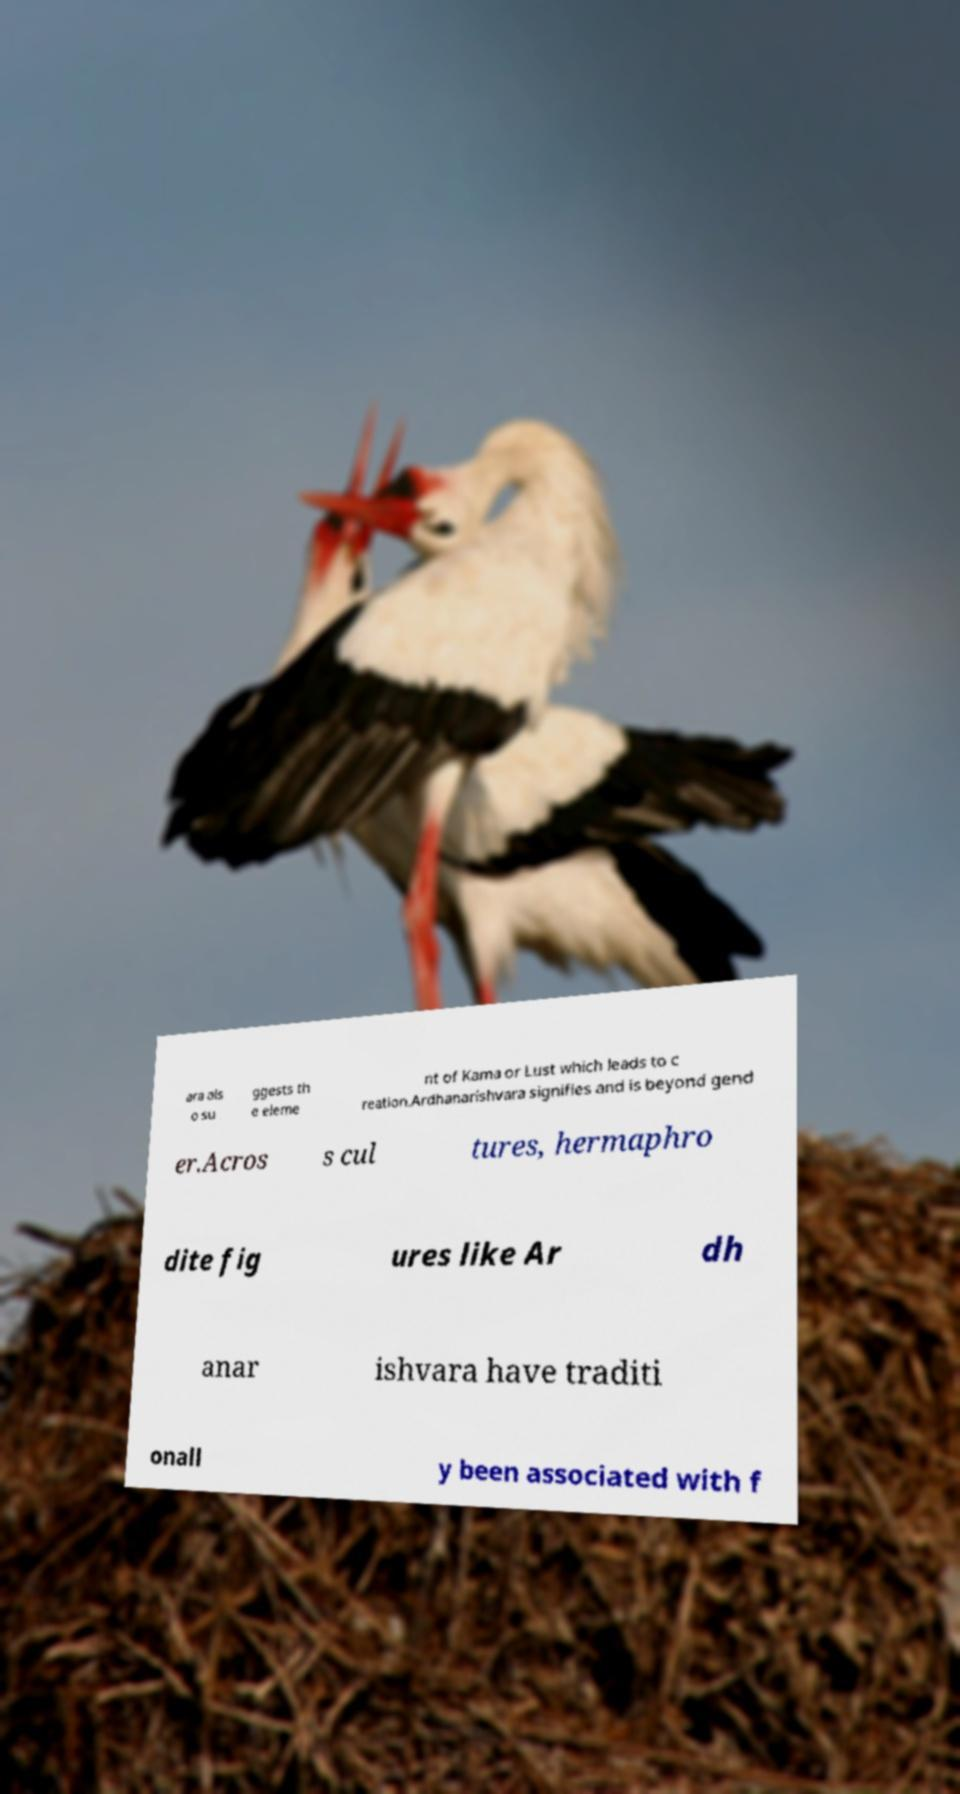For documentation purposes, I need the text within this image transcribed. Could you provide that? ara als o su ggests th e eleme nt of Kama or Lust which leads to c reation.Ardhanarishvara signifies and is beyond gend er.Acros s cul tures, hermaphro dite fig ures like Ar dh anar ishvara have traditi onall y been associated with f 